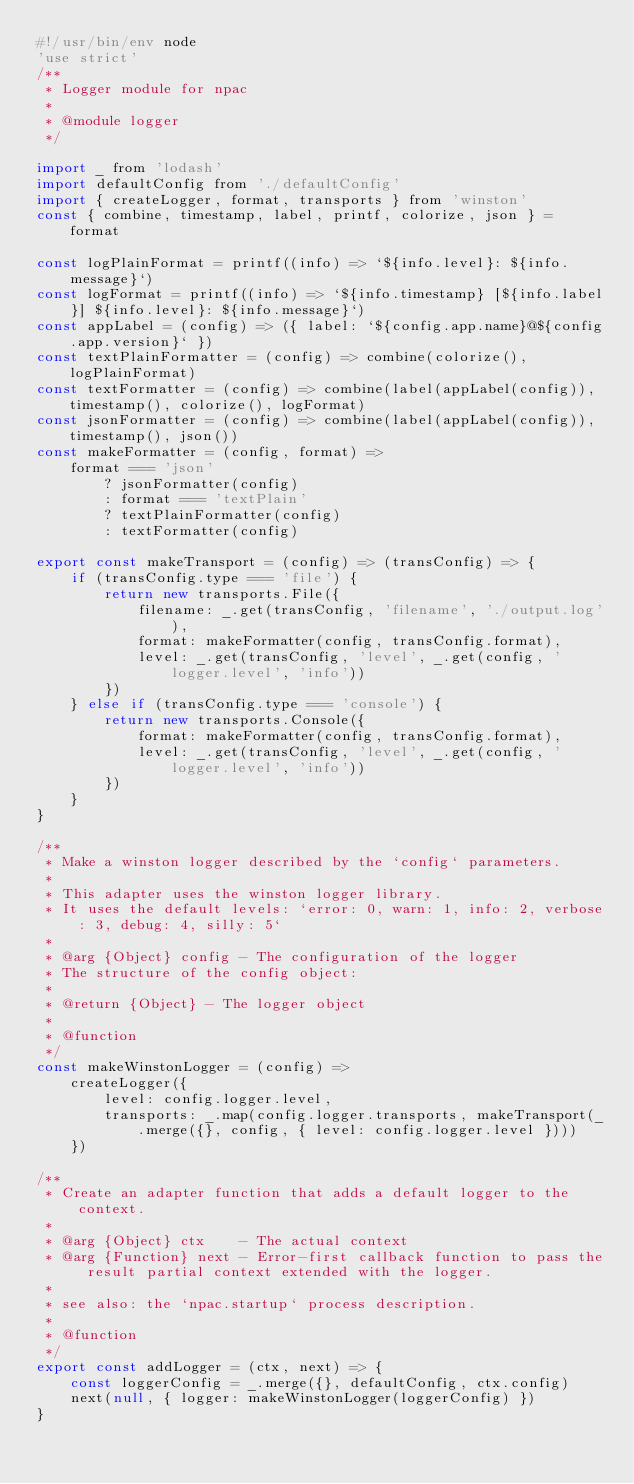<code> <loc_0><loc_0><loc_500><loc_500><_JavaScript_>#!/usr/bin/env node
'use strict'
/**
 * Logger module for npac
 *
 * @module logger
 */

import _ from 'lodash'
import defaultConfig from './defaultConfig'
import { createLogger, format, transports } from 'winston'
const { combine, timestamp, label, printf, colorize, json } = format

const logPlainFormat = printf((info) => `${info.level}: ${info.message}`)
const logFormat = printf((info) => `${info.timestamp} [${info.label}] ${info.level}: ${info.message}`)
const appLabel = (config) => ({ label: `${config.app.name}@${config.app.version}` })
const textPlainFormatter = (config) => combine(colorize(), logPlainFormat)
const textFormatter = (config) => combine(label(appLabel(config)), timestamp(), colorize(), logFormat)
const jsonFormatter = (config) => combine(label(appLabel(config)), timestamp(), json())
const makeFormatter = (config, format) =>
    format === 'json'
        ? jsonFormatter(config)
        : format === 'textPlain'
        ? textPlainFormatter(config)
        : textFormatter(config)

export const makeTransport = (config) => (transConfig) => {
    if (transConfig.type === 'file') {
        return new transports.File({
            filename: _.get(transConfig, 'filename', './output.log'),
            format: makeFormatter(config, transConfig.format),
            level: _.get(transConfig, 'level', _.get(config, 'logger.level', 'info'))
        })
    } else if (transConfig.type === 'console') {
        return new transports.Console({
            format: makeFormatter(config, transConfig.format),
            level: _.get(transConfig, 'level', _.get(config, 'logger.level', 'info'))
        })
    }
}

/**
 * Make a winston logger described by the `config` parameters.
 *
 * This adapter uses the winston logger library.
 * It uses the default levels: `error: 0, warn: 1, info: 2, verbose: 3, debug: 4, silly: 5`
 *
 * @arg {Object} config - The configuration of the logger
 * The structure of the config object:
 *
 * @return {Object} - The logger object
 *
 * @function
 */
const makeWinstonLogger = (config) =>
    createLogger({
        level: config.logger.level,
        transports: _.map(config.logger.transports, makeTransport(_.merge({}, config, { level: config.logger.level })))
    })

/**
 * Create an adapter function that adds a default logger to the context.
 *
 * @arg {Object} ctx    - The actual context
 * @arg {Function} next - Error-first callback function to pass the result partial context extended with the logger.
 *
 * see also: the `npac.startup` process description.
 *
 * @function
 */
export const addLogger = (ctx, next) => {
    const loggerConfig = _.merge({}, defaultConfig, ctx.config)
    next(null, { logger: makeWinstonLogger(loggerConfig) })
}
</code> 